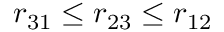<formula> <loc_0><loc_0><loc_500><loc_500>r _ { 3 1 } \leq r _ { 2 3 } \leq r _ { 1 2 }</formula> 